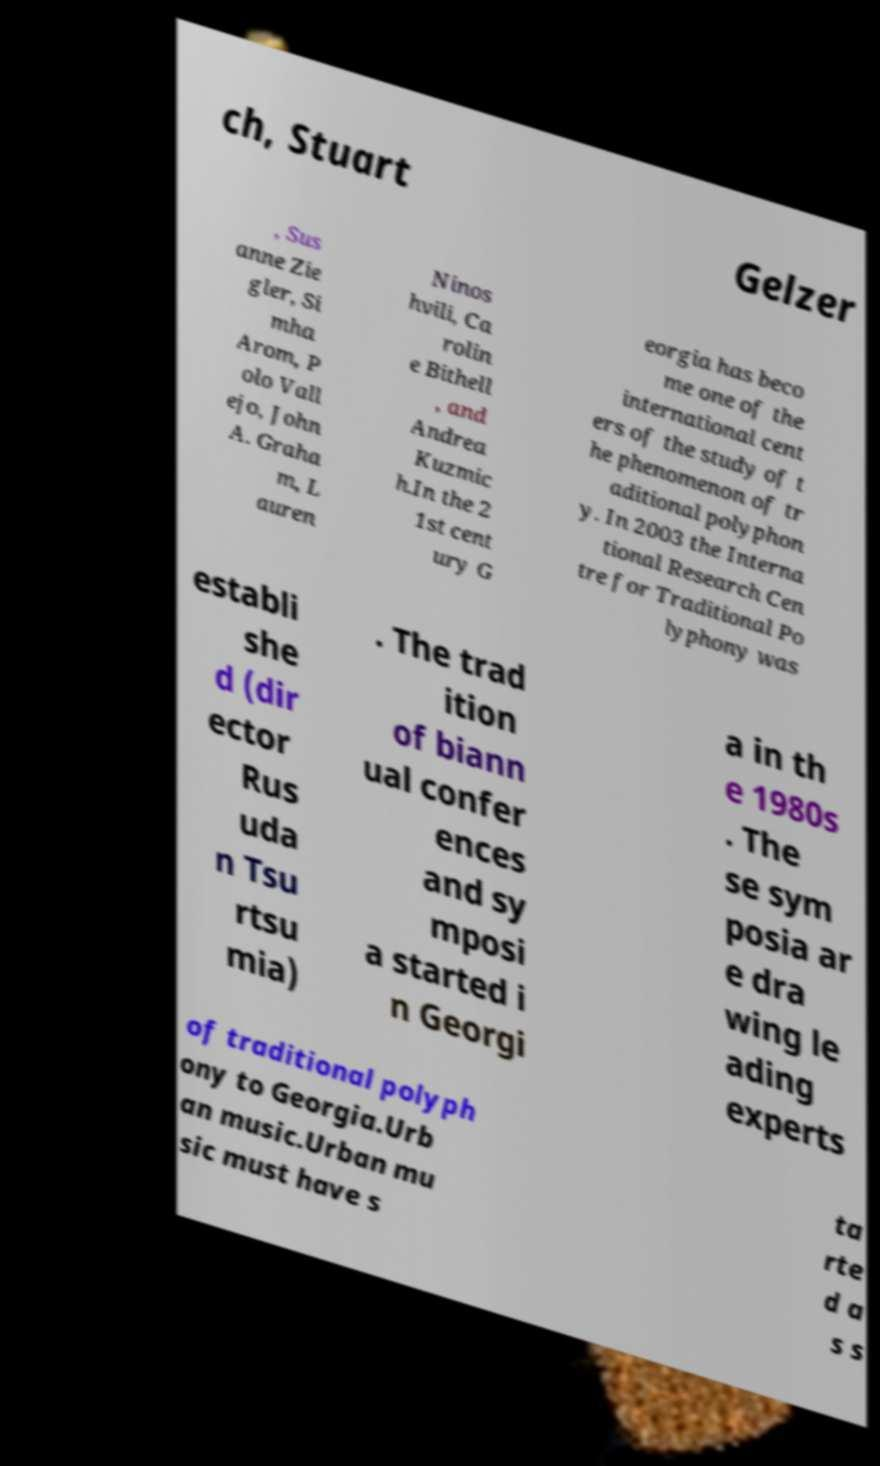Can you accurately transcribe the text from the provided image for me? ch, Stuart Gelzer , Sus anne Zie gler, Si mha Arom, P olo Vall ejo, John A. Graha m, L auren Ninos hvili, Ca rolin e Bithell , and Andrea Kuzmic h.In the 2 1st cent ury G eorgia has beco me one of the international cent ers of the study of t he phenomenon of tr aditional polyphon y. In 2003 the Interna tional Research Cen tre for Traditional Po lyphony was establi she d (dir ector Rus uda n Tsu rtsu mia) . The trad ition of biann ual confer ences and sy mposi a started i n Georgi a in th e 1980s . The se sym posia ar e dra wing le ading experts of traditional polyph ony to Georgia.Urb an music.Urban mu sic must have s ta rte d a s s 